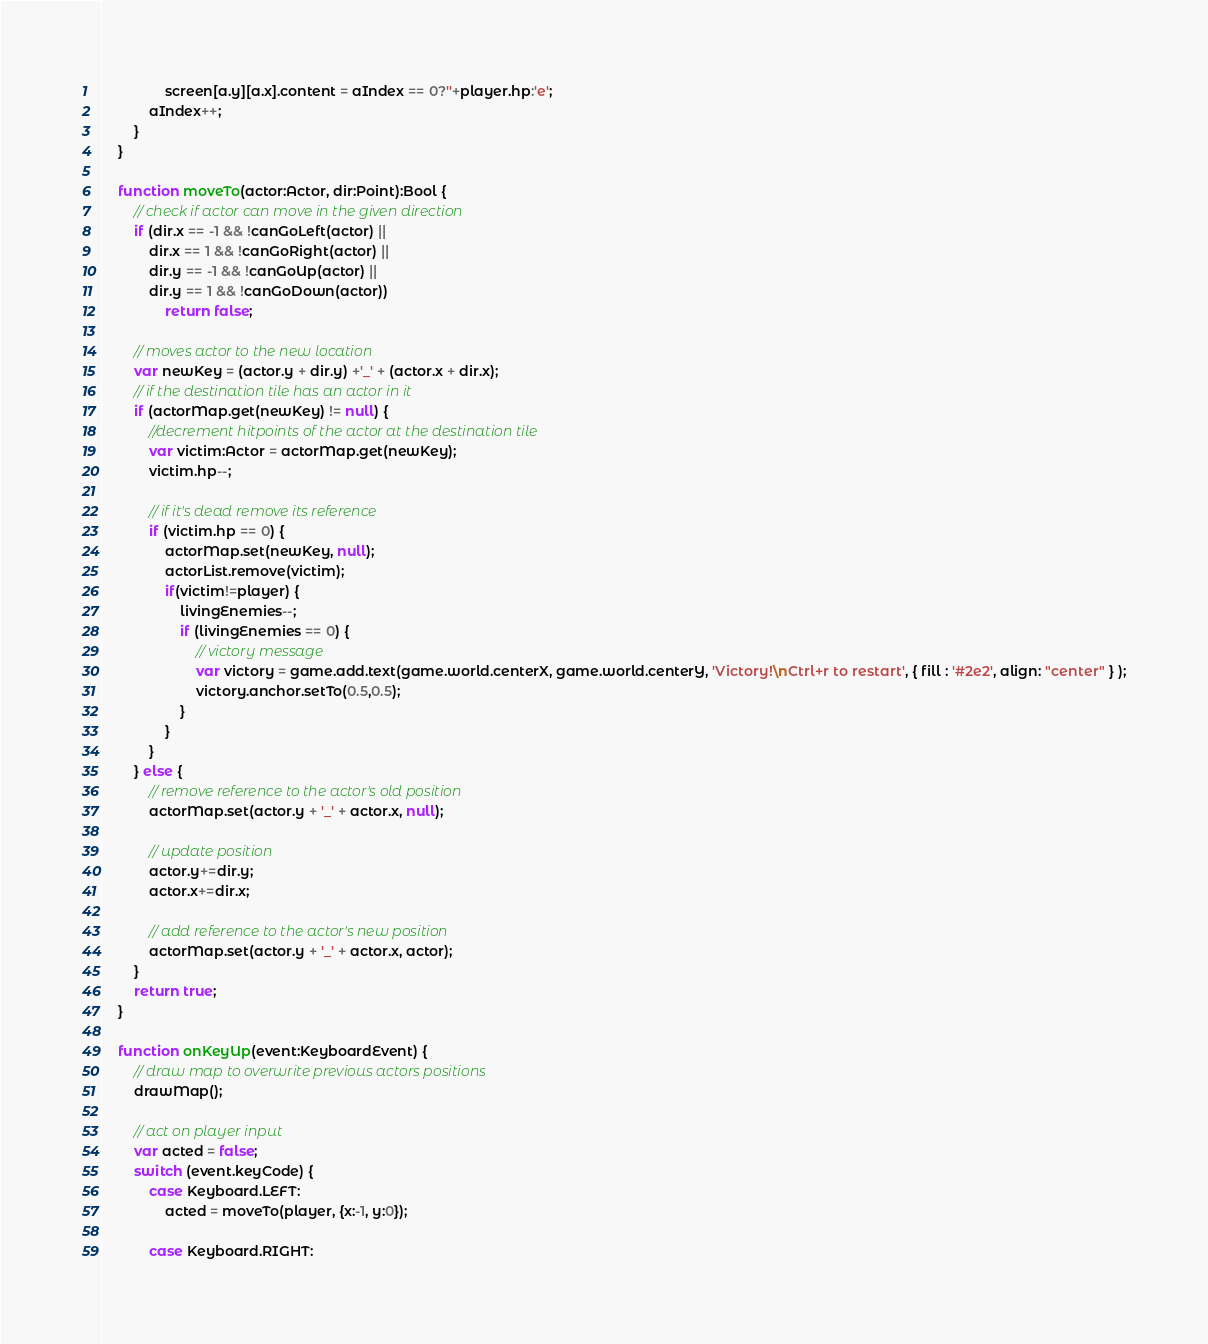<code> <loc_0><loc_0><loc_500><loc_500><_Haxe_>				screen[a.y][a.x].content = aIndex == 0?''+player.hp:'e';
			aIndex++;
		}
	}
	
	function moveTo(actor:Actor, dir:Point):Bool {
		// check if actor can move in the given direction
		if (dir.x == -1 && !canGoLeft(actor) || 
			dir.x == 1 && !canGoRight(actor) ||
			dir.y == -1 && !canGoUp(actor) || 
			dir.y == 1 && !canGoDown(actor)) 
				return false;
		
		// moves actor to the new location
		var newKey = (actor.y + dir.y) +'_' + (actor.x + dir.x);
		// if the destination tile has an actor in it 
		if (actorMap.get(newKey) != null) {
			//decrement hitpoints of the actor at the destination tile
			var victim:Actor = actorMap.get(newKey);
			victim.hp--;
			
			// if it's dead remove its reference 
			if (victim.hp == 0) {
				actorMap.set(newKey, null);
				actorList.remove(victim);
				if(victim!=player) {
					livingEnemies--;
					if (livingEnemies == 0) {
						// victory message
						var victory = game.add.text(game.world.centerX, game.world.centerY, 'Victory!\nCtrl+r to restart', { fill : '#2e2', align: "center" } );
						victory.anchor.setTo(0.5,0.5);
					}
				}
			}
		} else {
			// remove reference to the actor's old position
			actorMap.set(actor.y + '_' + actor.x, null);
			
			// update position
			actor.y+=dir.y;
			actor.x+=dir.x;

			// add reference to the actor's new position
			actorMap.set(actor.y + '_' + actor.x, actor);
		}
		return true;
	}
	
	function onKeyUp(event:KeyboardEvent) {
		// draw map to overwrite previous actors positions
		drawMap();
		
		// act on player input
		var acted = false;
		switch (event.keyCode) {
			case Keyboard.LEFT:
				acted = moveTo(player, {x:-1, y:0});
					
			case Keyboard.RIGHT:</code> 